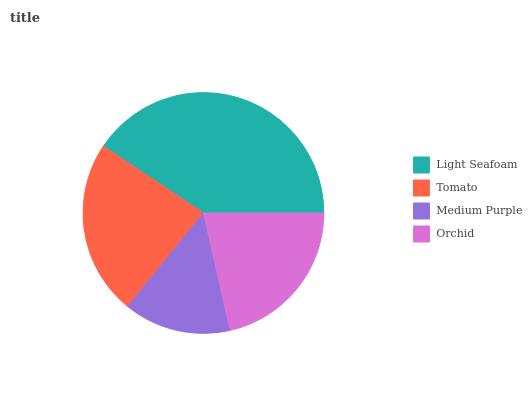Is Medium Purple the minimum?
Answer yes or no. Yes. Is Light Seafoam the maximum?
Answer yes or no. Yes. Is Tomato the minimum?
Answer yes or no. No. Is Tomato the maximum?
Answer yes or no. No. Is Light Seafoam greater than Tomato?
Answer yes or no. Yes. Is Tomato less than Light Seafoam?
Answer yes or no. Yes. Is Tomato greater than Light Seafoam?
Answer yes or no. No. Is Light Seafoam less than Tomato?
Answer yes or no. No. Is Tomato the high median?
Answer yes or no. Yes. Is Orchid the low median?
Answer yes or no. Yes. Is Orchid the high median?
Answer yes or no. No. Is Light Seafoam the low median?
Answer yes or no. No. 